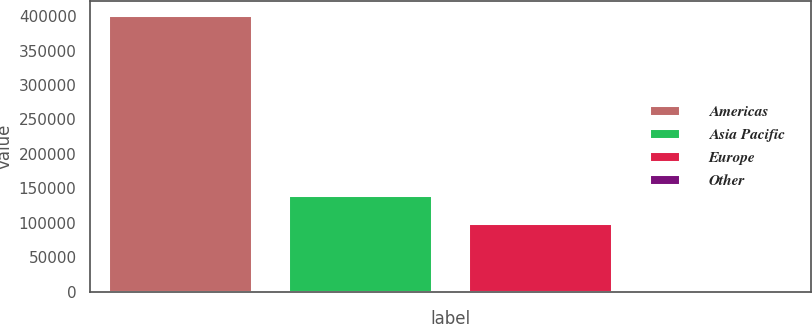Convert chart. <chart><loc_0><loc_0><loc_500><loc_500><bar_chart><fcel>Americas<fcel>Asia Pacific<fcel>Europe<fcel>Other<nl><fcel>402370<fcel>139954<fcel>99835<fcel>1178<nl></chart> 